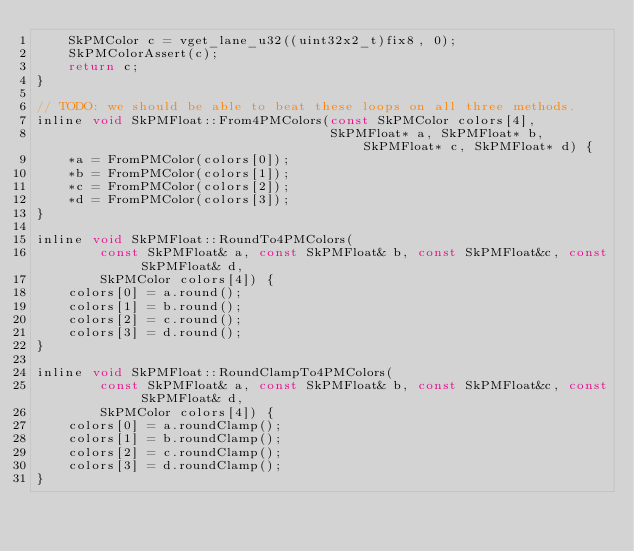Convert code to text. <code><loc_0><loc_0><loc_500><loc_500><_C_>    SkPMColor c = vget_lane_u32((uint32x2_t)fix8, 0);
    SkPMColorAssert(c);
    return c;
}

// TODO: we should be able to beat these loops on all three methods.
inline void SkPMFloat::From4PMColors(const SkPMColor colors[4],
                                     SkPMFloat* a, SkPMFloat* b, SkPMFloat* c, SkPMFloat* d) {
    *a = FromPMColor(colors[0]);
    *b = FromPMColor(colors[1]);
    *c = FromPMColor(colors[2]);
    *d = FromPMColor(colors[3]);
}

inline void SkPMFloat::RoundTo4PMColors(
        const SkPMFloat& a, const SkPMFloat& b, const SkPMFloat&c, const SkPMFloat& d,
        SkPMColor colors[4]) {
    colors[0] = a.round();
    colors[1] = b.round();
    colors[2] = c.round();
    colors[3] = d.round();
}

inline void SkPMFloat::RoundClampTo4PMColors(
        const SkPMFloat& a, const SkPMFloat& b, const SkPMFloat&c, const SkPMFloat& d,
        SkPMColor colors[4]) {
    colors[0] = a.roundClamp();
    colors[1] = b.roundClamp();
    colors[2] = c.roundClamp();
    colors[3] = d.roundClamp();
}
</code> 